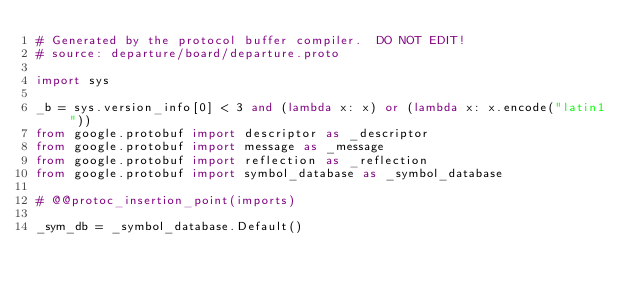Convert code to text. <code><loc_0><loc_0><loc_500><loc_500><_Python_># Generated by the protocol buffer compiler.  DO NOT EDIT!
# source: departure/board/departure.proto

import sys

_b = sys.version_info[0] < 3 and (lambda x: x) or (lambda x: x.encode("latin1"))
from google.protobuf import descriptor as _descriptor
from google.protobuf import message as _message
from google.protobuf import reflection as _reflection
from google.protobuf import symbol_database as _symbol_database

# @@protoc_insertion_point(imports)

_sym_db = _symbol_database.Default()

</code> 